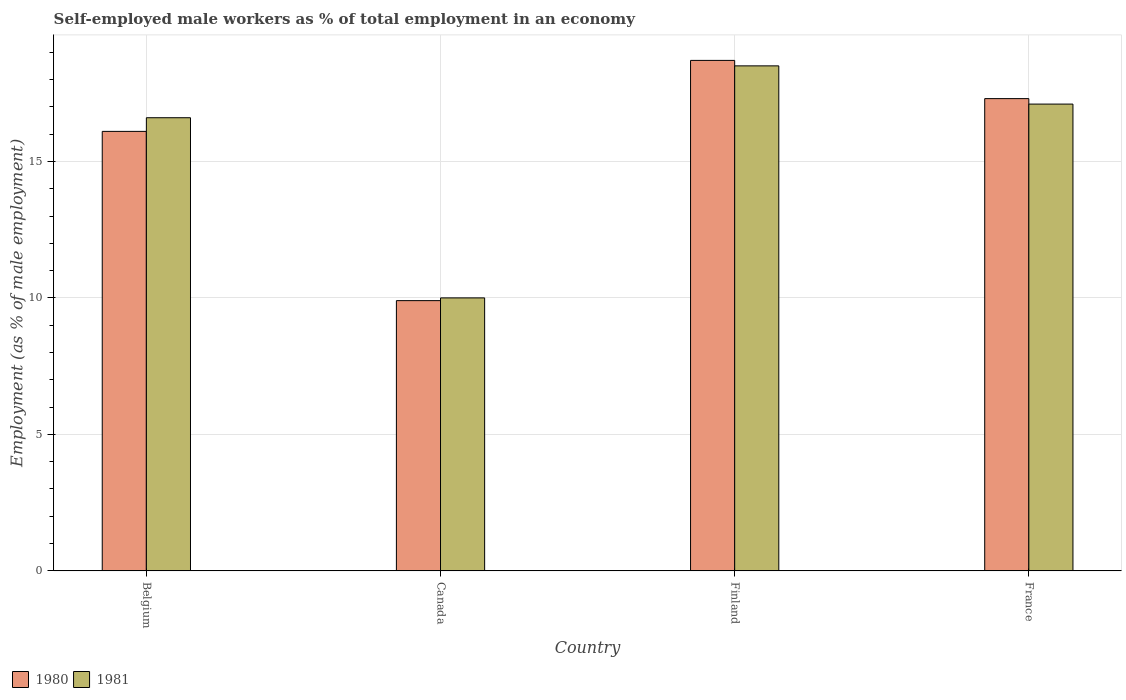Are the number of bars per tick equal to the number of legend labels?
Provide a succinct answer. Yes. What is the label of the 4th group of bars from the left?
Give a very brief answer. France. In how many cases, is the number of bars for a given country not equal to the number of legend labels?
Your answer should be compact. 0. What is the percentage of self-employed male workers in 1980 in France?
Give a very brief answer. 17.3. Across all countries, what is the maximum percentage of self-employed male workers in 1981?
Keep it short and to the point. 18.5. Across all countries, what is the minimum percentage of self-employed male workers in 1980?
Your response must be concise. 9.9. In which country was the percentage of self-employed male workers in 1980 maximum?
Your answer should be compact. Finland. What is the total percentage of self-employed male workers in 1981 in the graph?
Make the answer very short. 62.2. What is the difference between the percentage of self-employed male workers in 1980 in Canada and that in Finland?
Offer a very short reply. -8.8. What is the difference between the percentage of self-employed male workers in 1980 in Canada and the percentage of self-employed male workers in 1981 in Belgium?
Keep it short and to the point. -6.7. What is the average percentage of self-employed male workers in 1981 per country?
Your response must be concise. 15.55. What is the difference between the percentage of self-employed male workers of/in 1981 and percentage of self-employed male workers of/in 1980 in Finland?
Make the answer very short. -0.2. What is the ratio of the percentage of self-employed male workers in 1980 in Belgium to that in France?
Give a very brief answer. 0.93. Is the difference between the percentage of self-employed male workers in 1981 in Belgium and France greater than the difference between the percentage of self-employed male workers in 1980 in Belgium and France?
Provide a short and direct response. Yes. What is the difference between the highest and the second highest percentage of self-employed male workers in 1981?
Make the answer very short. -0.5. What is the difference between the highest and the lowest percentage of self-employed male workers in 1981?
Make the answer very short. 8.5. In how many countries, is the percentage of self-employed male workers in 1981 greater than the average percentage of self-employed male workers in 1981 taken over all countries?
Keep it short and to the point. 3. Are all the bars in the graph horizontal?
Offer a terse response. No. How many countries are there in the graph?
Ensure brevity in your answer.  4. Where does the legend appear in the graph?
Provide a succinct answer. Bottom left. How many legend labels are there?
Give a very brief answer. 2. What is the title of the graph?
Ensure brevity in your answer.  Self-employed male workers as % of total employment in an economy. What is the label or title of the Y-axis?
Keep it short and to the point. Employment (as % of male employment). What is the Employment (as % of male employment) of 1980 in Belgium?
Ensure brevity in your answer.  16.1. What is the Employment (as % of male employment) in 1981 in Belgium?
Offer a terse response. 16.6. What is the Employment (as % of male employment) in 1980 in Canada?
Give a very brief answer. 9.9. What is the Employment (as % of male employment) of 1981 in Canada?
Keep it short and to the point. 10. What is the Employment (as % of male employment) of 1980 in Finland?
Offer a terse response. 18.7. What is the Employment (as % of male employment) of 1981 in Finland?
Provide a succinct answer. 18.5. What is the Employment (as % of male employment) in 1980 in France?
Your answer should be very brief. 17.3. What is the Employment (as % of male employment) of 1981 in France?
Give a very brief answer. 17.1. Across all countries, what is the maximum Employment (as % of male employment) of 1980?
Give a very brief answer. 18.7. Across all countries, what is the minimum Employment (as % of male employment) of 1980?
Your response must be concise. 9.9. What is the total Employment (as % of male employment) of 1980 in the graph?
Provide a succinct answer. 62. What is the total Employment (as % of male employment) of 1981 in the graph?
Ensure brevity in your answer.  62.2. What is the difference between the Employment (as % of male employment) in 1981 in Belgium and that in Finland?
Your answer should be very brief. -1.9. What is the difference between the Employment (as % of male employment) in 1980 in Belgium and that in France?
Offer a very short reply. -1.2. What is the difference between the Employment (as % of male employment) in 1981 in Belgium and that in France?
Keep it short and to the point. -0.5. What is the difference between the Employment (as % of male employment) of 1980 in Canada and that in France?
Provide a succinct answer. -7.4. What is the difference between the Employment (as % of male employment) in 1980 in Finland and that in France?
Your response must be concise. 1.4. What is the difference between the Employment (as % of male employment) of 1980 in Finland and the Employment (as % of male employment) of 1981 in France?
Your response must be concise. 1.6. What is the average Employment (as % of male employment) of 1980 per country?
Give a very brief answer. 15.5. What is the average Employment (as % of male employment) in 1981 per country?
Provide a succinct answer. 15.55. What is the difference between the Employment (as % of male employment) in 1980 and Employment (as % of male employment) in 1981 in Belgium?
Provide a short and direct response. -0.5. What is the difference between the Employment (as % of male employment) of 1980 and Employment (as % of male employment) of 1981 in Canada?
Offer a terse response. -0.1. What is the difference between the Employment (as % of male employment) in 1980 and Employment (as % of male employment) in 1981 in France?
Give a very brief answer. 0.2. What is the ratio of the Employment (as % of male employment) of 1980 in Belgium to that in Canada?
Your answer should be compact. 1.63. What is the ratio of the Employment (as % of male employment) in 1981 in Belgium to that in Canada?
Your answer should be very brief. 1.66. What is the ratio of the Employment (as % of male employment) of 1980 in Belgium to that in Finland?
Keep it short and to the point. 0.86. What is the ratio of the Employment (as % of male employment) of 1981 in Belgium to that in Finland?
Provide a succinct answer. 0.9. What is the ratio of the Employment (as % of male employment) of 1980 in Belgium to that in France?
Offer a very short reply. 0.93. What is the ratio of the Employment (as % of male employment) of 1981 in Belgium to that in France?
Ensure brevity in your answer.  0.97. What is the ratio of the Employment (as % of male employment) in 1980 in Canada to that in Finland?
Ensure brevity in your answer.  0.53. What is the ratio of the Employment (as % of male employment) of 1981 in Canada to that in Finland?
Your answer should be compact. 0.54. What is the ratio of the Employment (as % of male employment) in 1980 in Canada to that in France?
Keep it short and to the point. 0.57. What is the ratio of the Employment (as % of male employment) of 1981 in Canada to that in France?
Keep it short and to the point. 0.58. What is the ratio of the Employment (as % of male employment) of 1980 in Finland to that in France?
Give a very brief answer. 1.08. What is the ratio of the Employment (as % of male employment) in 1981 in Finland to that in France?
Make the answer very short. 1.08. What is the difference between the highest and the second highest Employment (as % of male employment) in 1981?
Provide a short and direct response. 1.4. What is the difference between the highest and the lowest Employment (as % of male employment) in 1981?
Make the answer very short. 8.5. 